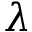<formula> <loc_0><loc_0><loc_500><loc_500>\lambda</formula> 